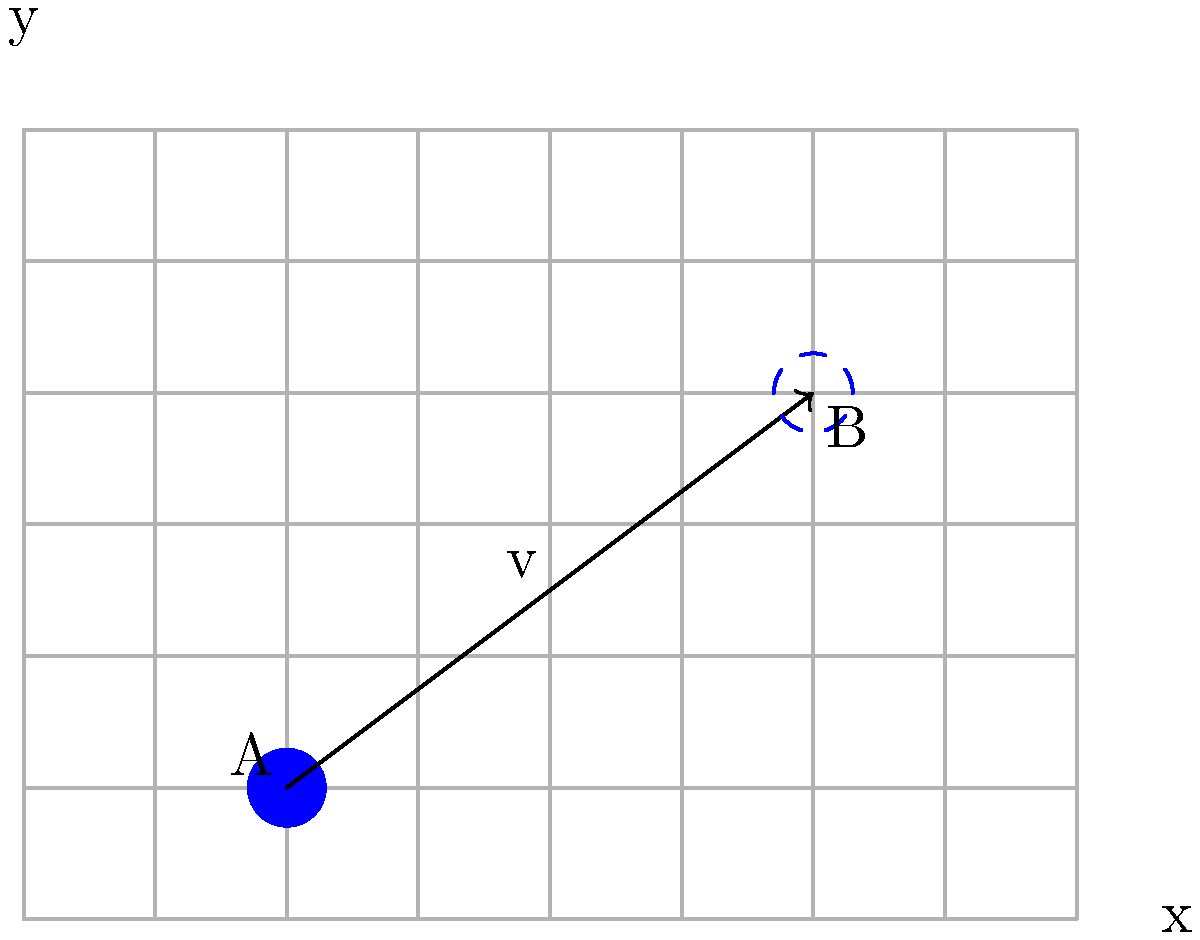On a dispatch board, truck A is initially at position (2, 1). The truck moves along vector v to reach position B. If v represents a translation of 4 units right and 3 units up, what are the coordinates of the truck's final position B? To solve this problem, we need to understand how translation works in transformational geometry:

1. The initial position of the truck A is at coordinates (2, 1).

2. The translation vector v moves the truck:
   - 4 units to the right (positive x-direction)
   - 3 units up (positive y-direction)

3. To find the final position B, we add the components of the translation vector to the initial coordinates:
   - New x-coordinate: $2 + 4 = 6$
   - New y-coordinate: $1 + 3 = 4$

4. Therefore, the final position B has coordinates (6, 4).

This can be represented mathematically as:

$$(x_B, y_B) = (x_A + v_x, y_A + v_y) = (2 + 4, 1 + 3) = (6, 4)$$

where $(x_A, y_A)$ are the initial coordinates, and $(v_x, v_y)$ are the components of the translation vector.
Answer: (6, 4) 